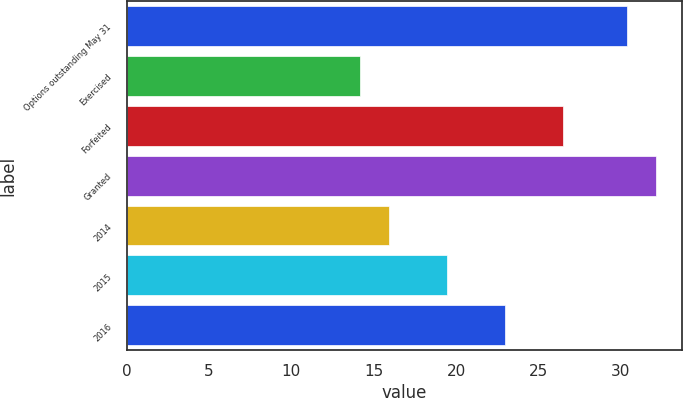Convert chart to OTSL. <chart><loc_0><loc_0><loc_500><loc_500><bar_chart><fcel>Options outstanding May 31<fcel>Exercised<fcel>Forfeited<fcel>Granted<fcel>2014<fcel>2015<fcel>2016<nl><fcel>30.38<fcel>14.15<fcel>26.47<fcel>32.14<fcel>15.91<fcel>19.43<fcel>22.95<nl></chart> 